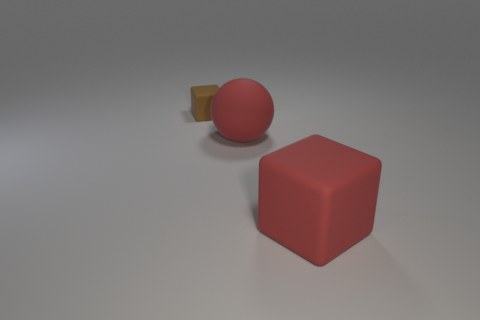What number of objects are balls or purple objects? In the image, there is 1 ball, and it appears to be red in color. There are no purple objects visible. So, the total number of objects that are either balls or purple is 1. 